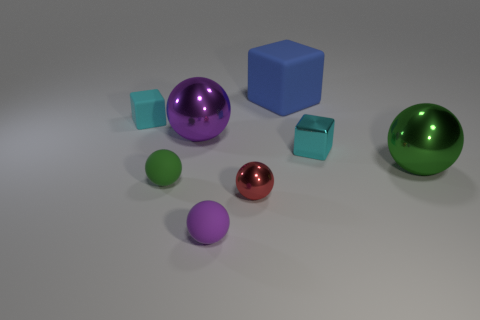Subtract 3 spheres. How many spheres are left? 2 Subtract all red balls. How many balls are left? 4 Subtract all tiny blocks. How many blocks are left? 1 Subtract all brown balls. Subtract all purple cylinders. How many balls are left? 5 Add 2 blue spheres. How many objects exist? 10 Subtract all balls. How many objects are left? 3 Subtract 0 purple blocks. How many objects are left? 8 Subtract all tiny green rubber cylinders. Subtract all purple metallic spheres. How many objects are left? 7 Add 4 tiny cyan rubber things. How many tiny cyan rubber things are left? 5 Add 4 big brown matte cylinders. How many big brown matte cylinders exist? 4 